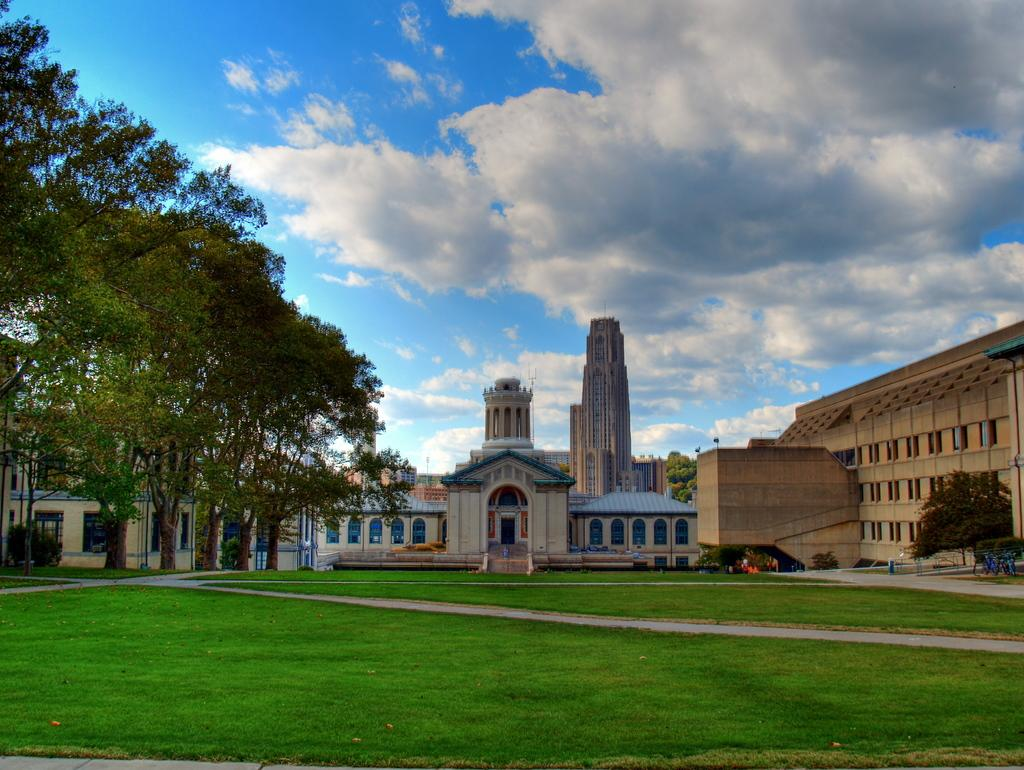What type of structures can be seen in the image? There are buildings in the image. What type of vegetation is present in the image? There are trees in the image. What type of ground cover is visible in the image? There is grass visible in the image. What part of the natural environment is visible in the image? The sky is visible in the image. What color is the chalk used to draw on the flag in the image? There is no chalk or flag present in the image. How does the grass in the image help the people slip and slide? There is no indication in the image that the grass is causing anyone to slip or slide. 